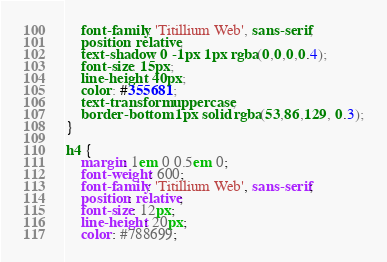<code> <loc_0><loc_0><loc_500><loc_500><_CSS_>	font-family: 'Titillium Web', sans-serif;
	position: relative;
	text-shadow: 0 -1px 1px rgba(0,0,0,0.4);
	font-size: 15px;
	line-height: 40px;
	color: #355681;
	text-transform: uppercase;
	border-bottom: 1px solid rgba(53,86,129, 0.3);
}

h4 {
	margin: 1em 0 0.5em 0;
	font-weight: 600;
	font-family: 'Titillium Web', sans-serif;
	position: relative;
	font-size: 12px;
	line-height: 20px;
	color: #788699;</code> 